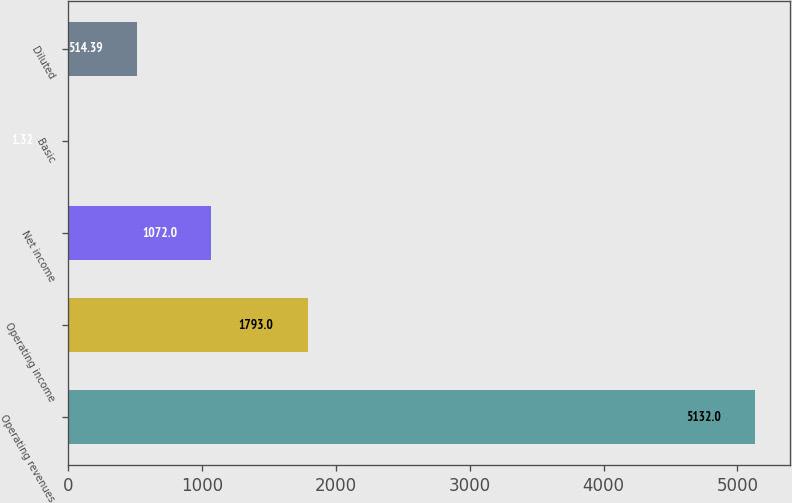<chart> <loc_0><loc_0><loc_500><loc_500><bar_chart><fcel>Operating revenues<fcel>Operating income<fcel>Net income<fcel>Basic<fcel>Diluted<nl><fcel>5132<fcel>1793<fcel>1072<fcel>1.32<fcel>514.39<nl></chart> 